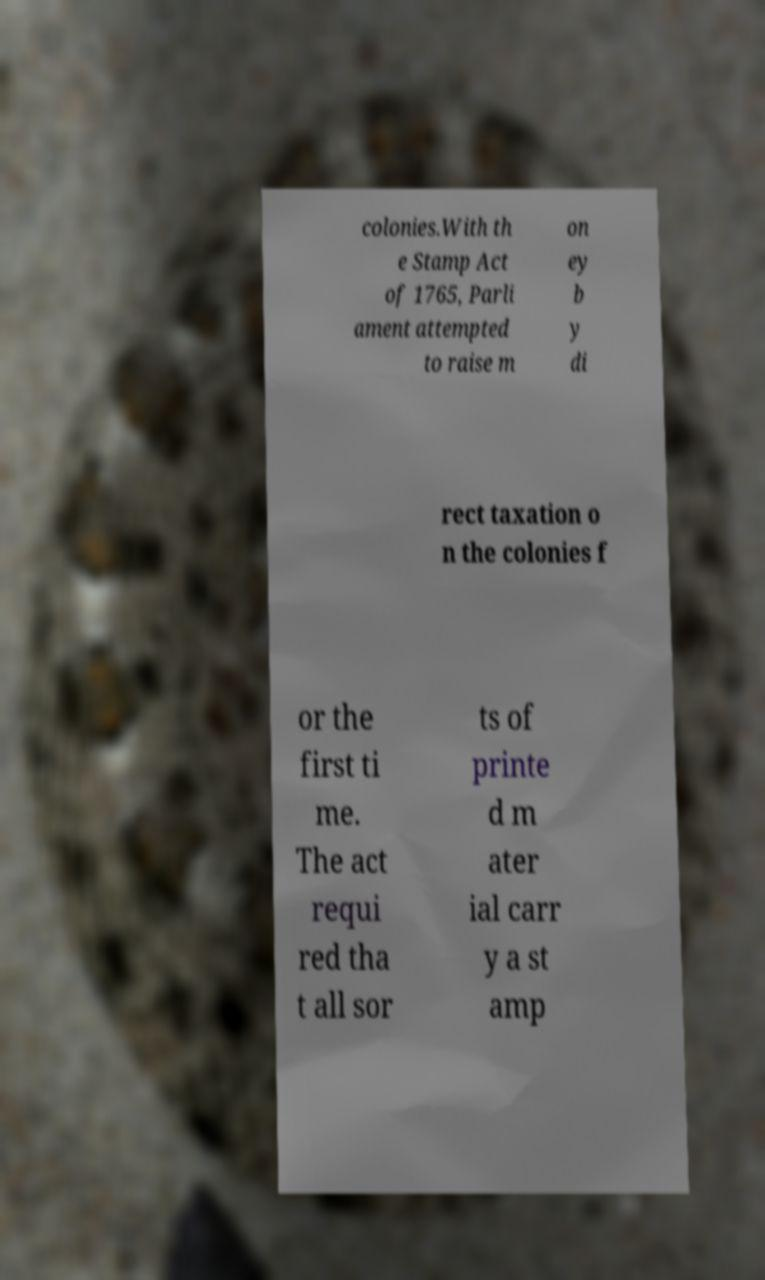Can you accurately transcribe the text from the provided image for me? colonies.With th e Stamp Act of 1765, Parli ament attempted to raise m on ey b y di rect taxation o n the colonies f or the first ti me. The act requi red tha t all sor ts of printe d m ater ial carr y a st amp 